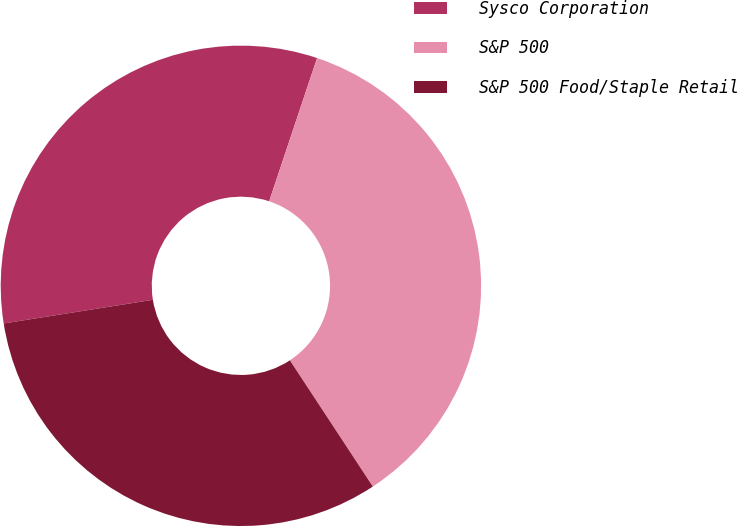Convert chart to OTSL. <chart><loc_0><loc_0><loc_500><loc_500><pie_chart><fcel>Sysco Corporation<fcel>S&P 500<fcel>S&P 500 Food/Staple Retail<nl><fcel>32.64%<fcel>35.61%<fcel>31.75%<nl></chart> 